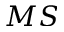Convert formula to latex. <formula><loc_0><loc_0><loc_500><loc_500>M S</formula> 